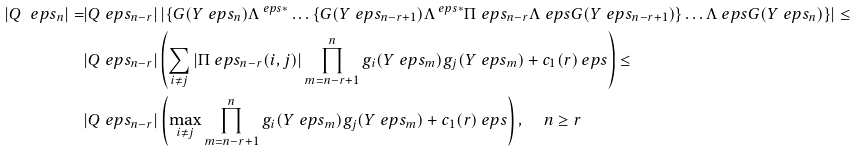Convert formula to latex. <formula><loc_0><loc_0><loc_500><loc_500>| Q ^ { \ } e p s _ { n } | = & | Q ^ { \ } e p s _ { n - r } | \left | \left \{ G ( Y ^ { \ } e p s _ { n } ) \Lambda ^ { \ e p s * } \dots \left \{ G ( Y ^ { \ } e p s _ { n - r + 1 } ) \Lambda ^ { \ e p s * } \Pi ^ { \ } e p s _ { n - r } \Lambda ^ { \ } e p s G ( Y ^ { \ } e p s _ { n - r + 1 } ) \right \} \dots \Lambda ^ { \ } e p s G ( Y ^ { \ } e p s _ { n } ) \right \} \right | \leq \\ & | Q ^ { \ } e p s _ { n - r } | \left ( \sum _ { i \ne j } \left | \Pi ^ { \ } e p s _ { n - r } ( i , j ) \right | \prod _ { m = n - r + 1 } ^ { n } g _ { i } ( Y ^ { \ } e p s _ { m } ) g _ { j } ( Y ^ { \ } e p s _ { m } ) + c _ { 1 } ( r ) \ e p s \right ) \leq \\ & | Q ^ { \ } e p s _ { n - r } | \left ( \max _ { i \ne j } \prod _ { m = n - r + 1 } ^ { n } g _ { i } ( Y ^ { \ } e p s _ { m } ) g _ { j } ( Y ^ { \ } e p s _ { m } ) + c _ { 1 } ( r ) \ e p s \right ) , \quad n \geq r</formula> 